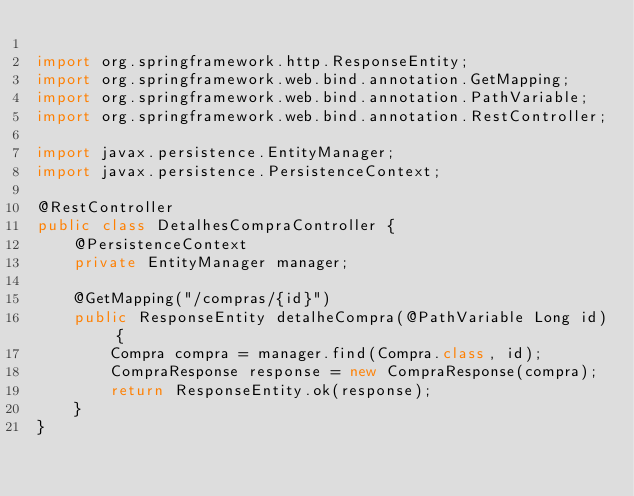Convert code to text. <code><loc_0><loc_0><loc_500><loc_500><_Java_>
import org.springframework.http.ResponseEntity;
import org.springframework.web.bind.annotation.GetMapping;
import org.springframework.web.bind.annotation.PathVariable;
import org.springframework.web.bind.annotation.RestController;

import javax.persistence.EntityManager;
import javax.persistence.PersistenceContext;

@RestController
public class DetalhesCompraController {
    @PersistenceContext
    private EntityManager manager;

    @GetMapping("/compras/{id}")
    public ResponseEntity detalheCompra(@PathVariable Long id) {
        Compra compra = manager.find(Compra.class, id);
        CompraResponse response = new CompraResponse(compra);
        return ResponseEntity.ok(response);
    }
}</code> 